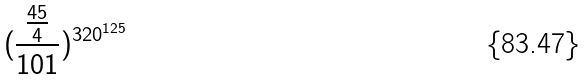<formula> <loc_0><loc_0><loc_500><loc_500>( \frac { \frac { 4 5 } { 4 } } { 1 0 1 } ) ^ { 3 2 0 ^ { 1 2 5 } }</formula> 